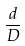<formula> <loc_0><loc_0><loc_500><loc_500>\frac { d } { D }</formula> 